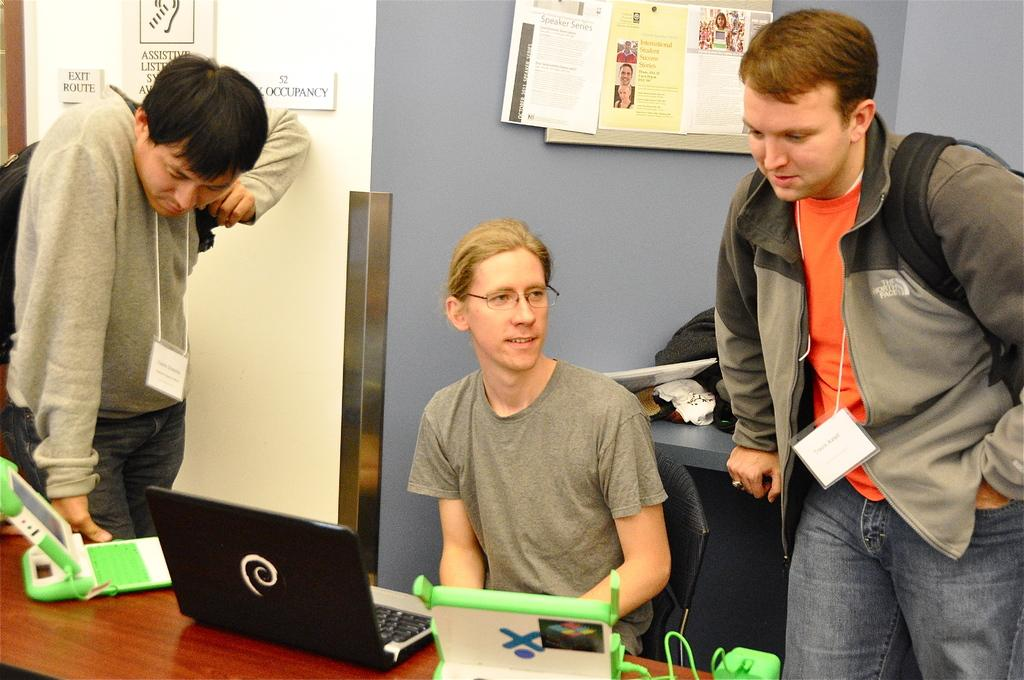How many men are present in the image? There are two men standing in the image, and one man is sitting. What is the sitting man doing in the image? The sitting man has a laptop in front of him on a table. What can be seen in the background of the image? There is a board and a wall visible in the background of the image. How does the wind affect the home in the image? There is no home or wind present in the image; it features three men and a background with a board and a wall. 